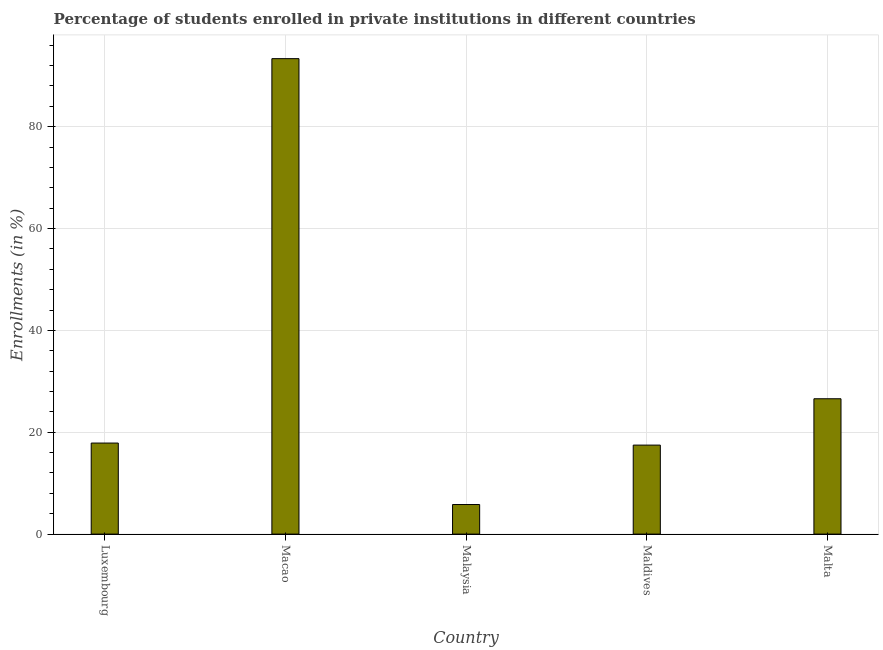Does the graph contain any zero values?
Provide a succinct answer. No. Does the graph contain grids?
Give a very brief answer. Yes. What is the title of the graph?
Offer a very short reply. Percentage of students enrolled in private institutions in different countries. What is the label or title of the Y-axis?
Offer a terse response. Enrollments (in %). What is the enrollments in private institutions in Luxembourg?
Your answer should be very brief. 17.88. Across all countries, what is the maximum enrollments in private institutions?
Your answer should be compact. 93.36. Across all countries, what is the minimum enrollments in private institutions?
Your response must be concise. 5.81. In which country was the enrollments in private institutions maximum?
Offer a terse response. Macao. In which country was the enrollments in private institutions minimum?
Keep it short and to the point. Malaysia. What is the sum of the enrollments in private institutions?
Make the answer very short. 161.1. What is the difference between the enrollments in private institutions in Macao and Malta?
Your answer should be compact. 66.78. What is the average enrollments in private institutions per country?
Offer a terse response. 32.22. What is the median enrollments in private institutions?
Give a very brief answer. 17.88. What is the ratio of the enrollments in private institutions in Macao to that in Malaysia?
Provide a short and direct response. 16.08. Is the enrollments in private institutions in Luxembourg less than that in Maldives?
Offer a very short reply. No. What is the difference between the highest and the second highest enrollments in private institutions?
Your response must be concise. 66.78. What is the difference between the highest and the lowest enrollments in private institutions?
Provide a succinct answer. 87.55. How many bars are there?
Provide a short and direct response. 5. Are all the bars in the graph horizontal?
Keep it short and to the point. No. How many countries are there in the graph?
Make the answer very short. 5. Are the values on the major ticks of Y-axis written in scientific E-notation?
Keep it short and to the point. No. What is the Enrollments (in %) in Luxembourg?
Your answer should be very brief. 17.88. What is the Enrollments (in %) in Macao?
Provide a succinct answer. 93.36. What is the Enrollments (in %) of Malaysia?
Your response must be concise. 5.81. What is the Enrollments (in %) of Maldives?
Offer a terse response. 17.48. What is the Enrollments (in %) in Malta?
Offer a terse response. 26.58. What is the difference between the Enrollments (in %) in Luxembourg and Macao?
Keep it short and to the point. -75.48. What is the difference between the Enrollments (in %) in Luxembourg and Malaysia?
Give a very brief answer. 12.07. What is the difference between the Enrollments (in %) in Luxembourg and Maldives?
Offer a very short reply. 0.4. What is the difference between the Enrollments (in %) in Luxembourg and Malta?
Your response must be concise. -8.7. What is the difference between the Enrollments (in %) in Macao and Malaysia?
Offer a terse response. 87.55. What is the difference between the Enrollments (in %) in Macao and Maldives?
Ensure brevity in your answer.  75.88. What is the difference between the Enrollments (in %) in Macao and Malta?
Your answer should be compact. 66.79. What is the difference between the Enrollments (in %) in Malaysia and Maldives?
Keep it short and to the point. -11.67. What is the difference between the Enrollments (in %) in Malaysia and Malta?
Your answer should be very brief. -20.77. What is the difference between the Enrollments (in %) in Maldives and Malta?
Provide a short and direct response. -9.1. What is the ratio of the Enrollments (in %) in Luxembourg to that in Macao?
Make the answer very short. 0.19. What is the ratio of the Enrollments (in %) in Luxembourg to that in Malaysia?
Keep it short and to the point. 3.08. What is the ratio of the Enrollments (in %) in Luxembourg to that in Malta?
Your answer should be very brief. 0.67. What is the ratio of the Enrollments (in %) in Macao to that in Malaysia?
Keep it short and to the point. 16.08. What is the ratio of the Enrollments (in %) in Macao to that in Maldives?
Give a very brief answer. 5.34. What is the ratio of the Enrollments (in %) in Macao to that in Malta?
Keep it short and to the point. 3.51. What is the ratio of the Enrollments (in %) in Malaysia to that in Maldives?
Your answer should be very brief. 0.33. What is the ratio of the Enrollments (in %) in Malaysia to that in Malta?
Your answer should be very brief. 0.22. What is the ratio of the Enrollments (in %) in Maldives to that in Malta?
Provide a succinct answer. 0.66. 